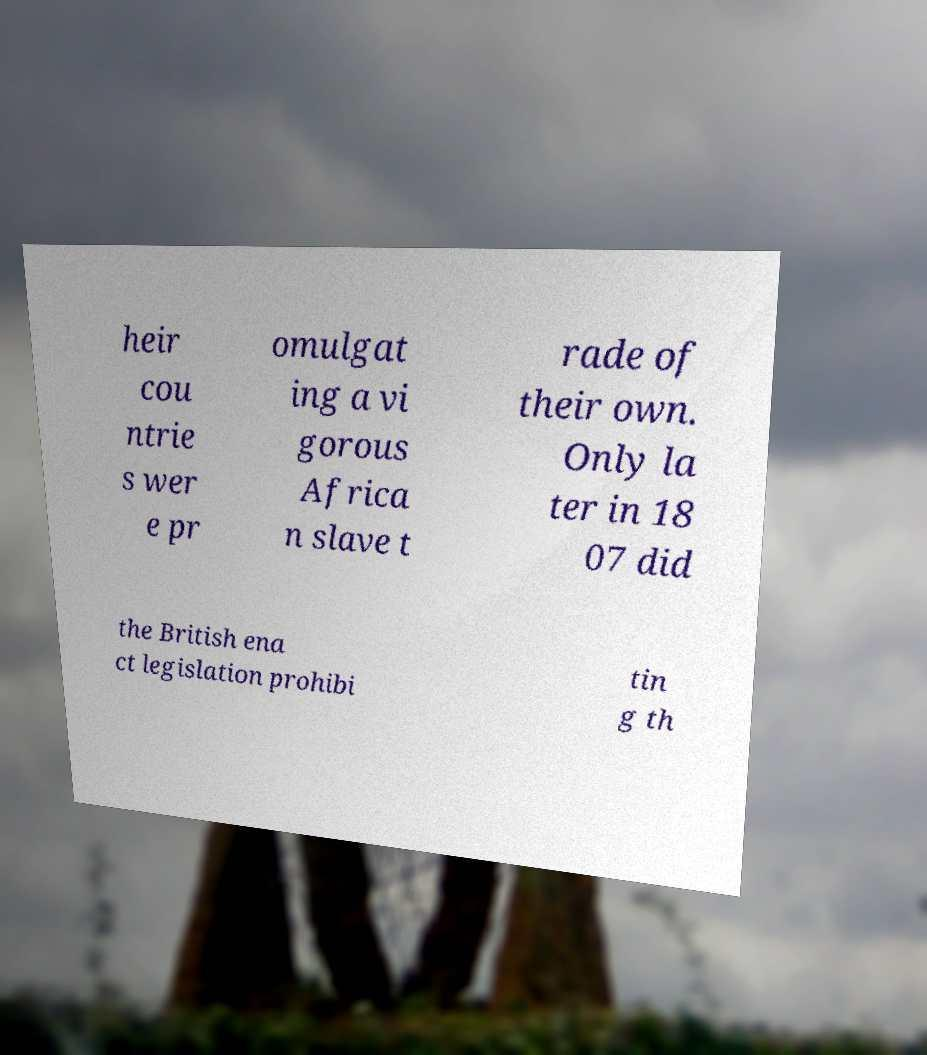What messages or text are displayed in this image? I need them in a readable, typed format. heir cou ntrie s wer e pr omulgat ing a vi gorous Africa n slave t rade of their own. Only la ter in 18 07 did the British ena ct legislation prohibi tin g th 